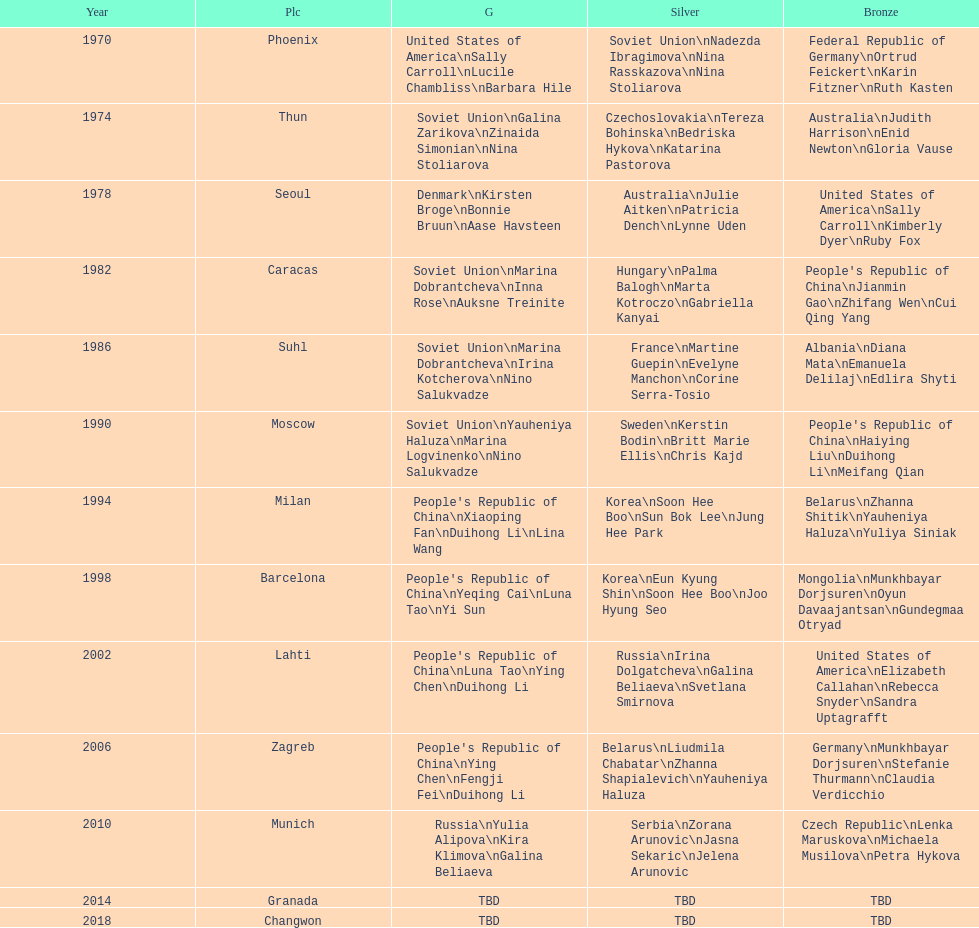How many times has germany won bronze? 2. 